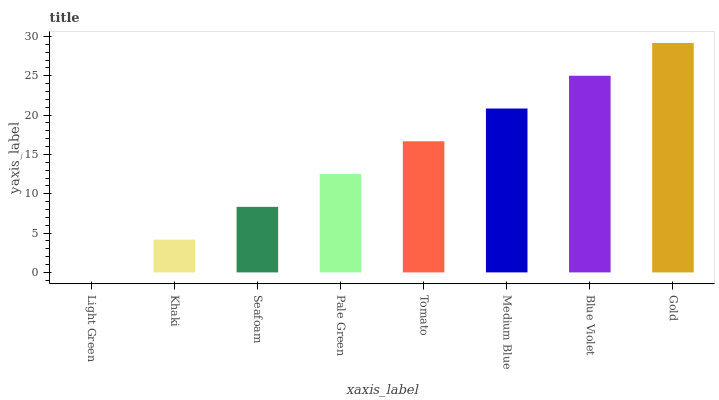Is Light Green the minimum?
Answer yes or no. Yes. Is Gold the maximum?
Answer yes or no. Yes. Is Khaki the minimum?
Answer yes or no. No. Is Khaki the maximum?
Answer yes or no. No. Is Khaki greater than Light Green?
Answer yes or no. Yes. Is Light Green less than Khaki?
Answer yes or no. Yes. Is Light Green greater than Khaki?
Answer yes or no. No. Is Khaki less than Light Green?
Answer yes or no. No. Is Tomato the high median?
Answer yes or no. Yes. Is Pale Green the low median?
Answer yes or no. Yes. Is Pale Green the high median?
Answer yes or no. No. Is Seafoam the low median?
Answer yes or no. No. 